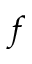Convert formula to latex. <formula><loc_0><loc_0><loc_500><loc_500>f</formula> 